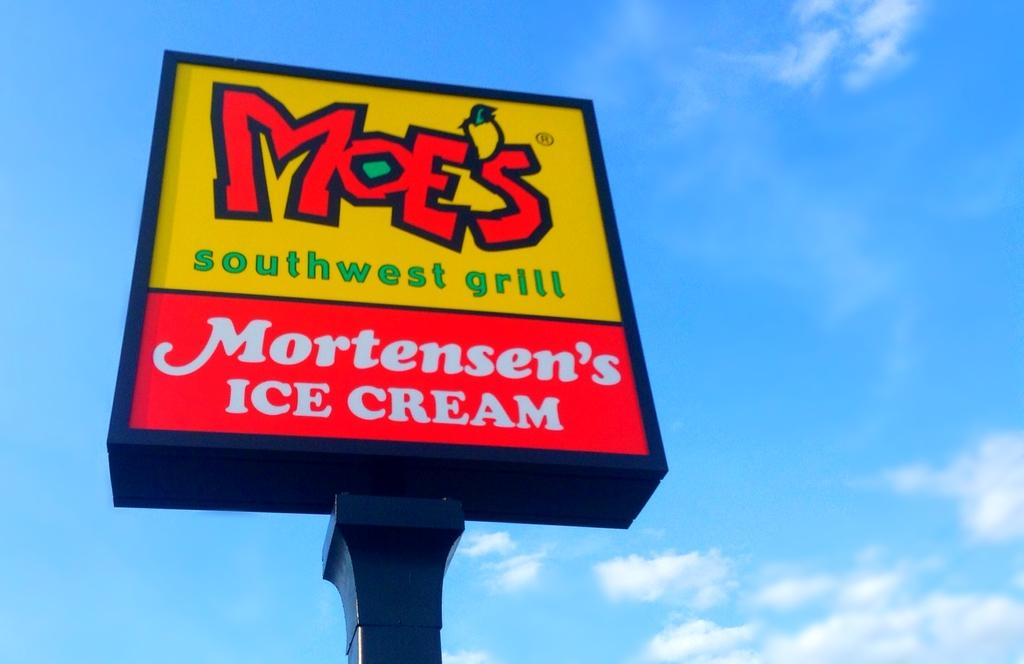<image>
Summarize the visual content of the image. The restaurant sign is for Moe's Southwest Grill 